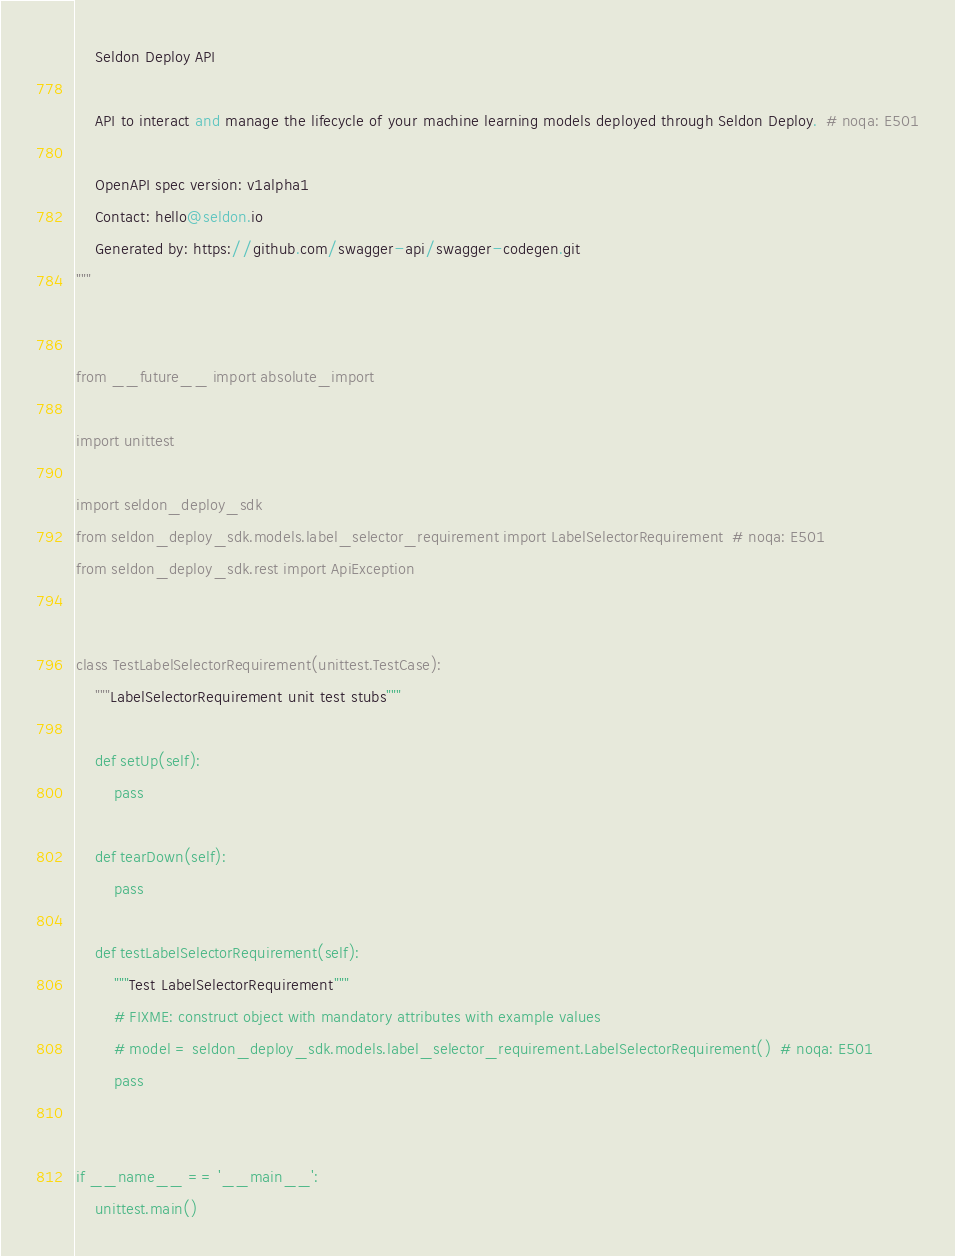Convert code to text. <code><loc_0><loc_0><loc_500><loc_500><_Python_>    Seldon Deploy API

    API to interact and manage the lifecycle of your machine learning models deployed through Seldon Deploy.  # noqa: E501

    OpenAPI spec version: v1alpha1
    Contact: hello@seldon.io
    Generated by: https://github.com/swagger-api/swagger-codegen.git
"""


from __future__ import absolute_import

import unittest

import seldon_deploy_sdk
from seldon_deploy_sdk.models.label_selector_requirement import LabelSelectorRequirement  # noqa: E501
from seldon_deploy_sdk.rest import ApiException


class TestLabelSelectorRequirement(unittest.TestCase):
    """LabelSelectorRequirement unit test stubs"""

    def setUp(self):
        pass

    def tearDown(self):
        pass

    def testLabelSelectorRequirement(self):
        """Test LabelSelectorRequirement"""
        # FIXME: construct object with mandatory attributes with example values
        # model = seldon_deploy_sdk.models.label_selector_requirement.LabelSelectorRequirement()  # noqa: E501
        pass


if __name__ == '__main__':
    unittest.main()
</code> 